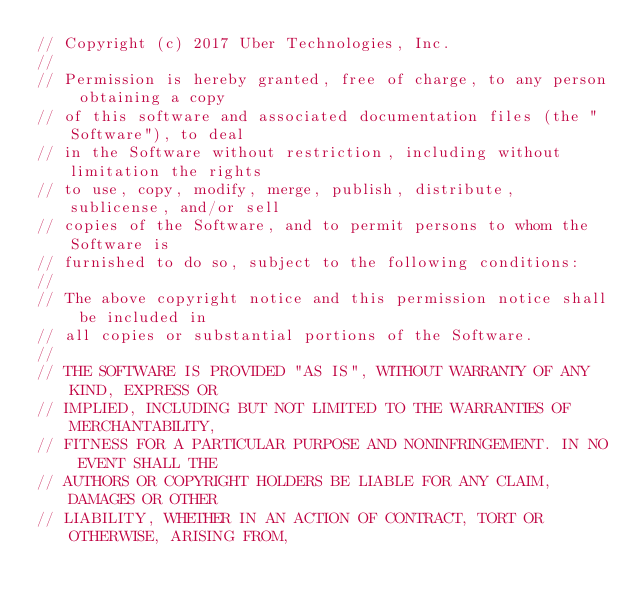<code> <loc_0><loc_0><loc_500><loc_500><_Go_>// Copyright (c) 2017 Uber Technologies, Inc.
//
// Permission is hereby granted, free of charge, to any person obtaining a copy
// of this software and associated documentation files (the "Software"), to deal
// in the Software without restriction, including without limitation the rights
// to use, copy, modify, merge, publish, distribute, sublicense, and/or sell
// copies of the Software, and to permit persons to whom the Software is
// furnished to do so, subject to the following conditions:
//
// The above copyright notice and this permission notice shall be included in
// all copies or substantial portions of the Software.
//
// THE SOFTWARE IS PROVIDED "AS IS", WITHOUT WARRANTY OF ANY KIND, EXPRESS OR
// IMPLIED, INCLUDING BUT NOT LIMITED TO THE WARRANTIES OF MERCHANTABILITY,
// FITNESS FOR A PARTICULAR PURPOSE AND NONINFRINGEMENT. IN NO EVENT SHALL THE
// AUTHORS OR COPYRIGHT HOLDERS BE LIABLE FOR ANY CLAIM, DAMAGES OR OTHER
// LIABILITY, WHETHER IN AN ACTION OF CONTRACT, TORT OR OTHERWISE, ARISING FROM,</code> 